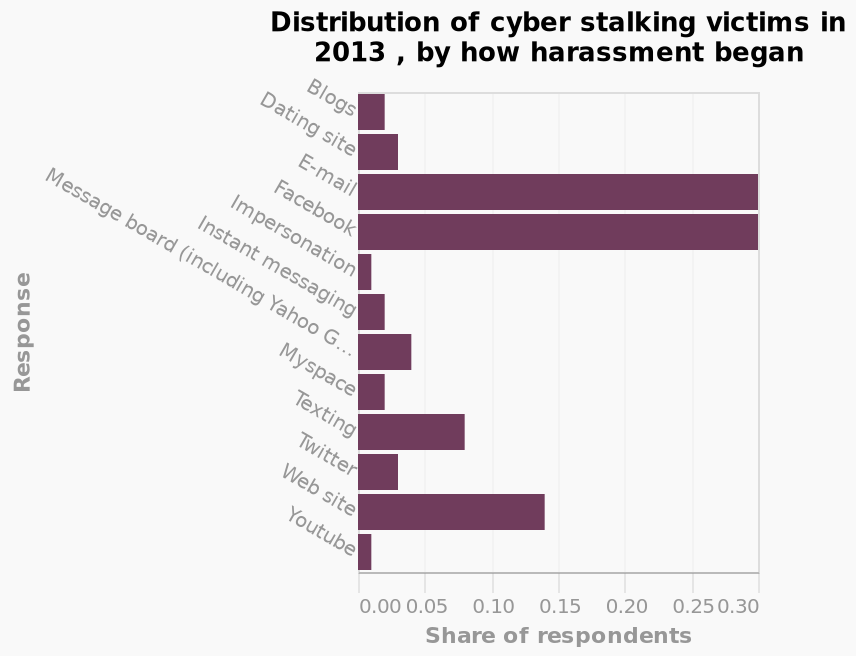<image>
How many categories are displayed on the y-axis of the bar graph? There are multiple categories displayed on the y-axis of the bar graph, ranging from Blogs to Youtube, representing different response types. please summary the statistics and relations of the chart Email and Facebook are the categories which have the highest share of respondents at the maximum 0.3. Websites are the next highest category at a 0.13 - 0.14 share of respondents. Texting is the next highest category at a 0.07 - 0.09 share. All the remaining categories have a much lower share of respondents compared to the inital categories described earlier. These remaining categories do not have a share greater than roughly 0.04. YouTube and impersonations are the categories with the lowest share at roughly 0.01 - 0.02. 